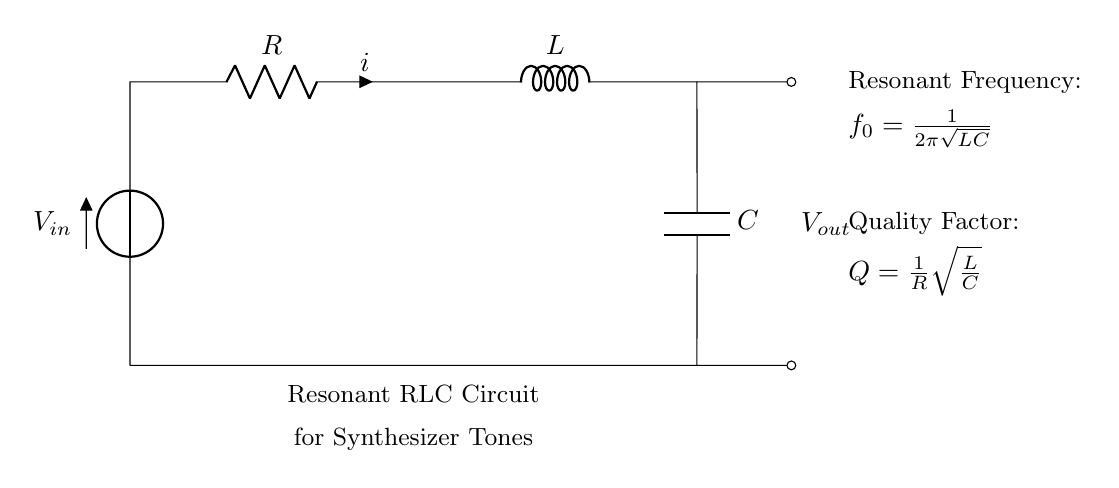What is the input voltage of this circuit? The input voltage, represented by \( V_{in} \), is the voltage supplied to the circuit at the leftmost position in the diagram.
Answer: V in What type of components are used in this circuit? The circuit consists of three main types of components: a resistor (R), an inductor (L), and a capacitor (C). These components are crucial for creating resonance.
Answer: Resistor, Inductor, Capacitor What is the formula for resonant frequency? The resonant frequency \( f_0 \) is given by the formula \( f_0 = \frac{1}{2\pi\sqrt{LC}} \), which relates the inductance (L) and capacitance (C) to the frequency.
Answer: 1 over 2 pi square root of LC How does the quality factor relate to resistance? The quality factor \( Q \) is defined as \( Q = \frac{1}{R}\sqrt{\frac{L}{C}} \), showing an inverse relationship between \( Q \) and \( R \); as resistance increases, quality factor decreases.
Answer: Q equals 1 over R square root of L over C What occurs when the circuit is at resonance? At resonance, the impedance of the circuit is minimized, and maximum current flows through, enhancing tone quality for synthesizers.
Answer: Maximum current 